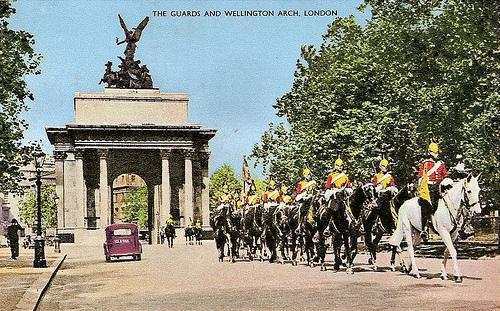How many cars are there?
Give a very brief answer. 1. 